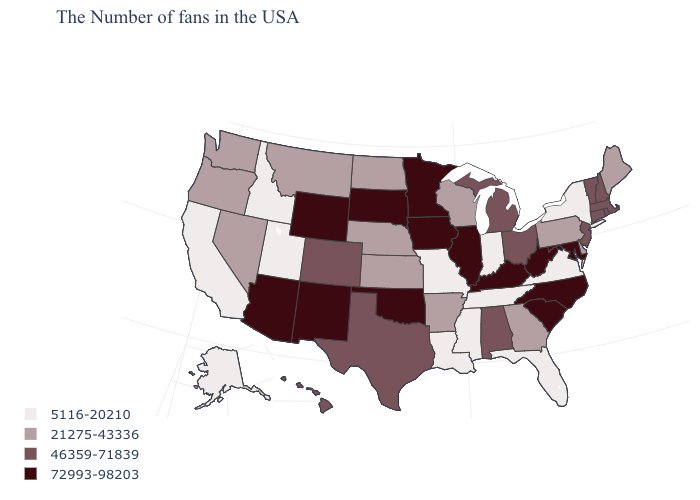What is the value of North Dakota?
Give a very brief answer. 21275-43336. What is the value of Wisconsin?
Concise answer only. 21275-43336. Among the states that border Oregon , does California have the lowest value?
Short answer required. Yes. Is the legend a continuous bar?
Concise answer only. No. What is the lowest value in states that border Iowa?
Be succinct. 5116-20210. What is the value of Arkansas?
Be succinct. 21275-43336. Does the first symbol in the legend represent the smallest category?
Keep it brief. Yes. Name the states that have a value in the range 5116-20210?
Keep it brief. New York, Virginia, Florida, Indiana, Tennessee, Mississippi, Louisiana, Missouri, Utah, Idaho, California, Alaska. What is the lowest value in the South?
Keep it brief. 5116-20210. What is the value of Pennsylvania?
Write a very short answer. 21275-43336. What is the value of Indiana?
Short answer required. 5116-20210. Among the states that border Arkansas , which have the lowest value?
Give a very brief answer. Tennessee, Mississippi, Louisiana, Missouri. Name the states that have a value in the range 21275-43336?
Be succinct. Maine, Delaware, Pennsylvania, Georgia, Wisconsin, Arkansas, Kansas, Nebraska, North Dakota, Montana, Nevada, Washington, Oregon. Which states have the lowest value in the USA?
Write a very short answer. New York, Virginia, Florida, Indiana, Tennessee, Mississippi, Louisiana, Missouri, Utah, Idaho, California, Alaska. Does the map have missing data?
Short answer required. No. 